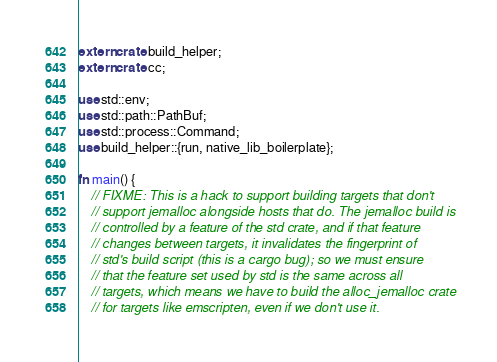<code> <loc_0><loc_0><loc_500><loc_500><_Rust_>
extern crate build_helper;
extern crate cc;

use std::env;
use std::path::PathBuf;
use std::process::Command;
use build_helper::{run, native_lib_boilerplate};

fn main() {
    // FIXME: This is a hack to support building targets that don't
    // support jemalloc alongside hosts that do. The jemalloc build is
    // controlled by a feature of the std crate, and if that feature
    // changes between targets, it invalidates the fingerprint of
    // std's build script (this is a cargo bug); so we must ensure
    // that the feature set used by std is the same across all
    // targets, which means we have to build the alloc_jemalloc crate
    // for targets like emscripten, even if we don't use it.</code> 